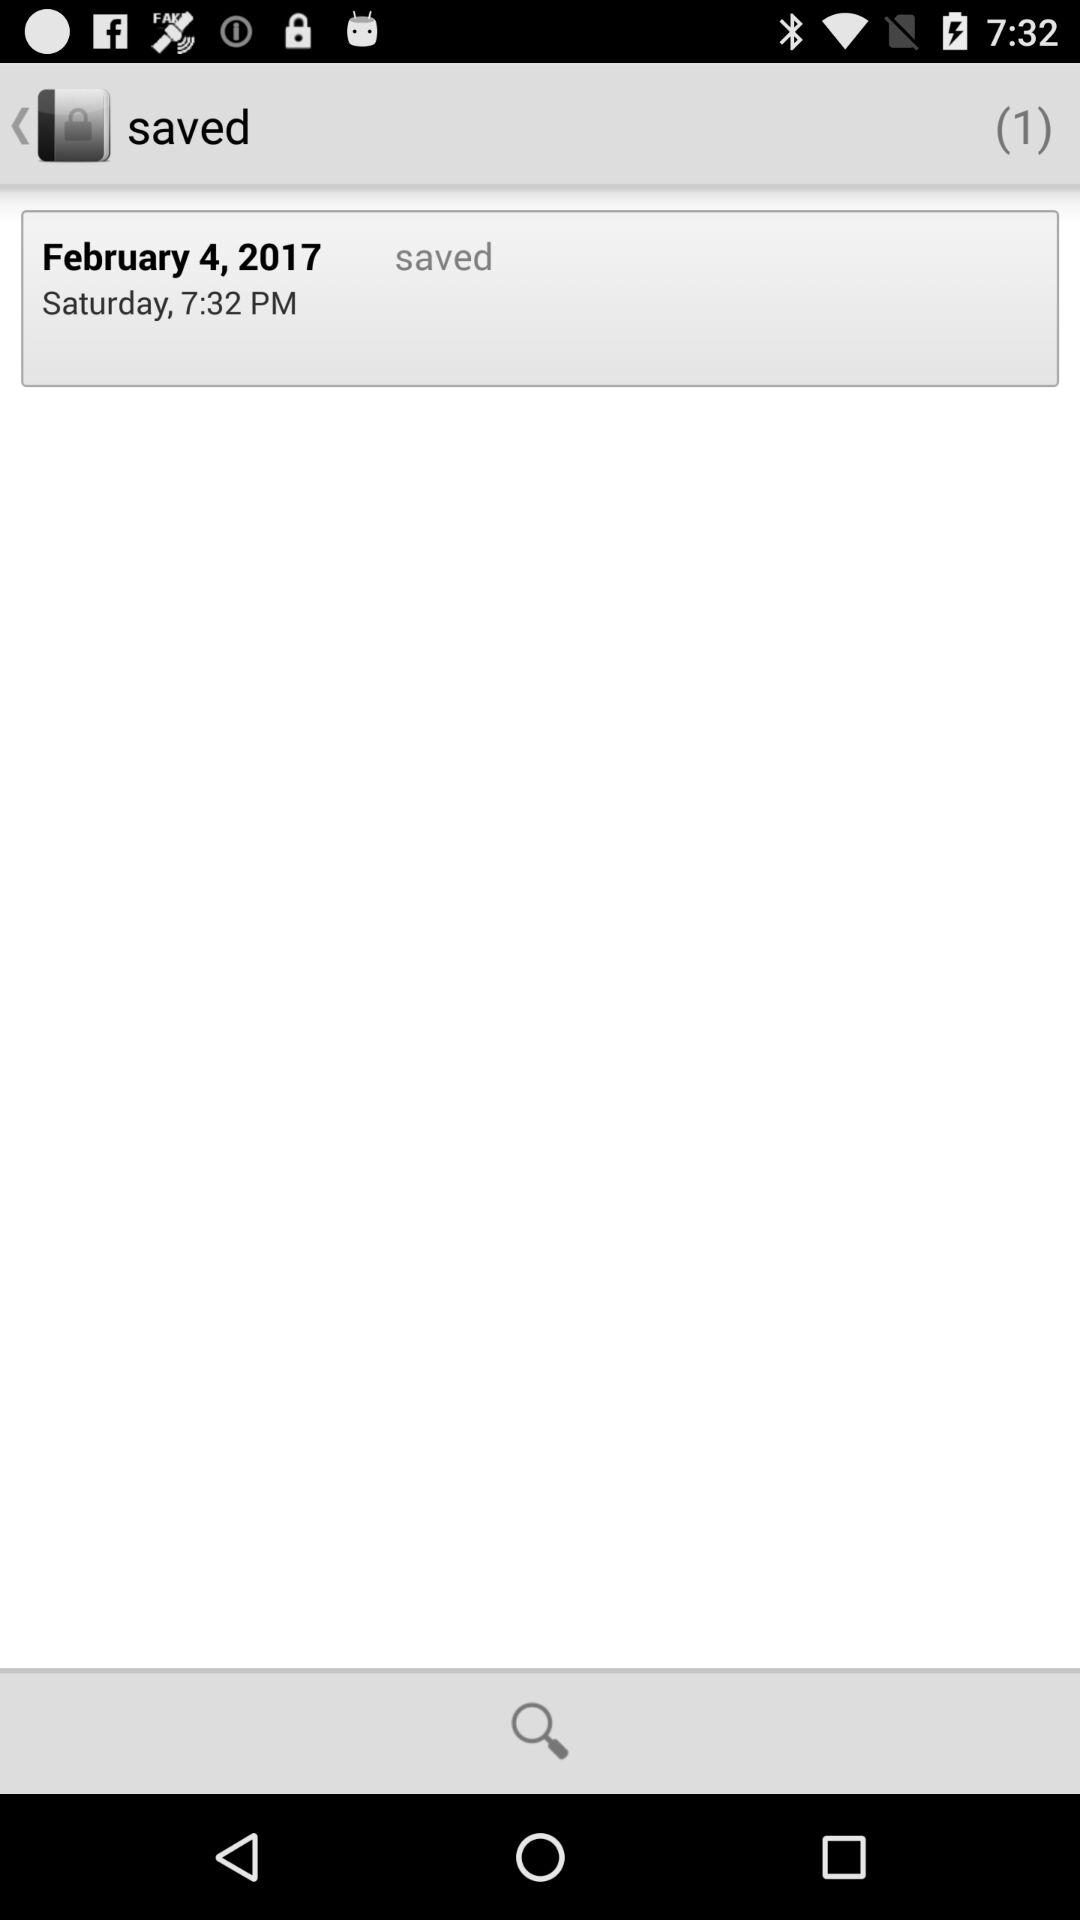At what time was the item saved? The item was saved at 7:32 PM. 